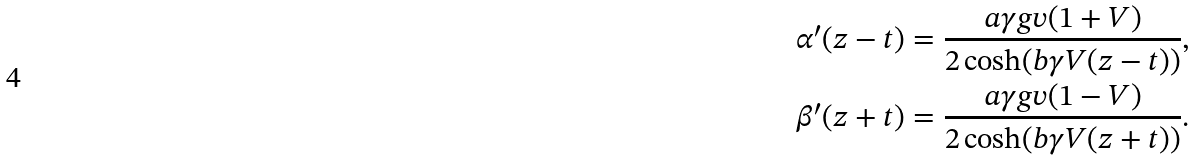Convert formula to latex. <formula><loc_0><loc_0><loc_500><loc_500>\alpha ^ { \prime } ( z - t ) & = \frac { a \gamma g v ( 1 + V ) } { 2 \cosh ( b \gamma V ( z - t ) ) } , \\ \beta ^ { \prime } ( z + t ) & = \frac { a \gamma g v ( 1 - V ) } { 2 \cosh ( b \gamma V ( z + t ) ) } .</formula> 